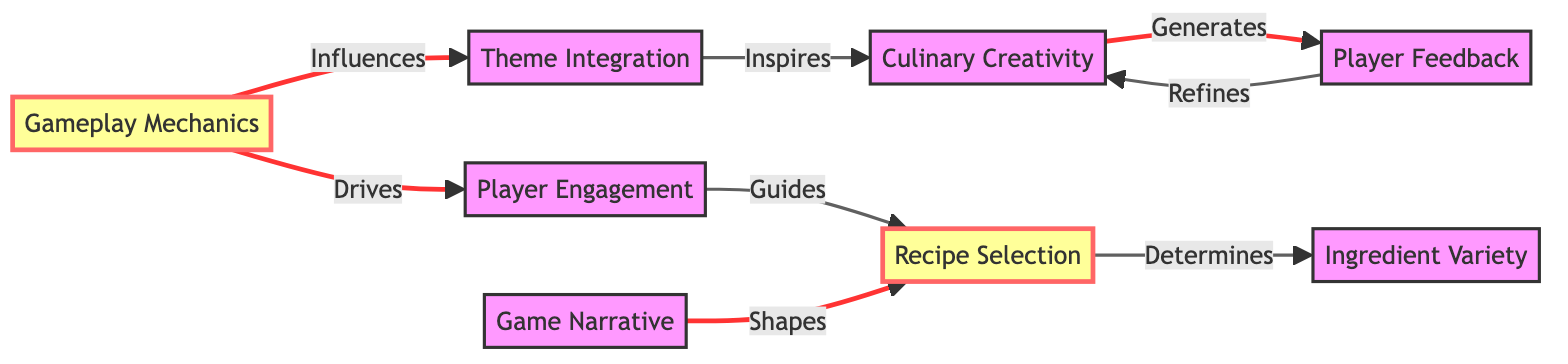What's the total number of nodes in the diagram? The diagram lists eight distinct nodes, which are Gameplay Mechanics, Theme Integration, Player Engagement, Culinary Creativity, Recipe Selection, Player Feedback, Ingredient Variety, and Game Narrative. By counting these, we find that there are a total of eight nodes.
Answer: 8 Which node is influenced by Gameplay Mechanics? According to the diagram, Theme Integration and Player Engagement are both directly influenced by Gameplay Mechanics. Since the question asks for a single node, the first one in the list is Theme Integration.
Answer: Theme Integration How many edges originate from Recipe Selection? The diagram shows that Recipe Selection has two outgoing edges: one to Ingredient Variety and the other from Game Narrative. Hence, Recipe Selection has two edges leading from it.
Answer: 2 What influences Culinary Creativity? Culinary Creativity is primarily inspired by Theme Integration, which is indicated by a directed edge from Theme Integration to Culinary Creativity. Therefore, the answer is Theme Integration.
Answer: Theme Integration What is the relationship between Player Engagement and Recipe Selection? The diagram indicates that Player Engagement guides Recipe Selection, which is represented by a directed edge pointing from Player Engagement to Recipe Selection. Therefore, the relationship can be described as "guides."
Answer: Guides How does Player Feedback affect Culinary Creativity? The diagram demonstrates that Player Feedback refines Culinary Creativity, as shown by the directed edge from Player Feedback to Culinary Creativity. This indicates that feedback from players leads to improvements or modifications in culinary creativity.
Answer: Refines Which node acts as the final destination for feedback in the diagram? The outgoing edge from Player Feedback indicates that it connects back to Culinary Creativity, making Culinary Creativity the final destination for feedback in the network of nodes.
Answer: Culinary Creativity How many nodes are directly connected to Game Mechanics? The diagram reveals that Game Mechanics has two direct connections: one leading to Theme Integration and another to Player Engagement. Counting these connections, we find there are two nodes directly connected to Game Mechanics.
Answer: 2 What generates Player Feedback? According to the diagram, Culinary Creativity generates Player Feedback, as indicated by the directed edge that flows from Culinary Creativity to Player Feedback. Therefore, the answer is Culinary Creativity.
Answer: Culinary Creativity 